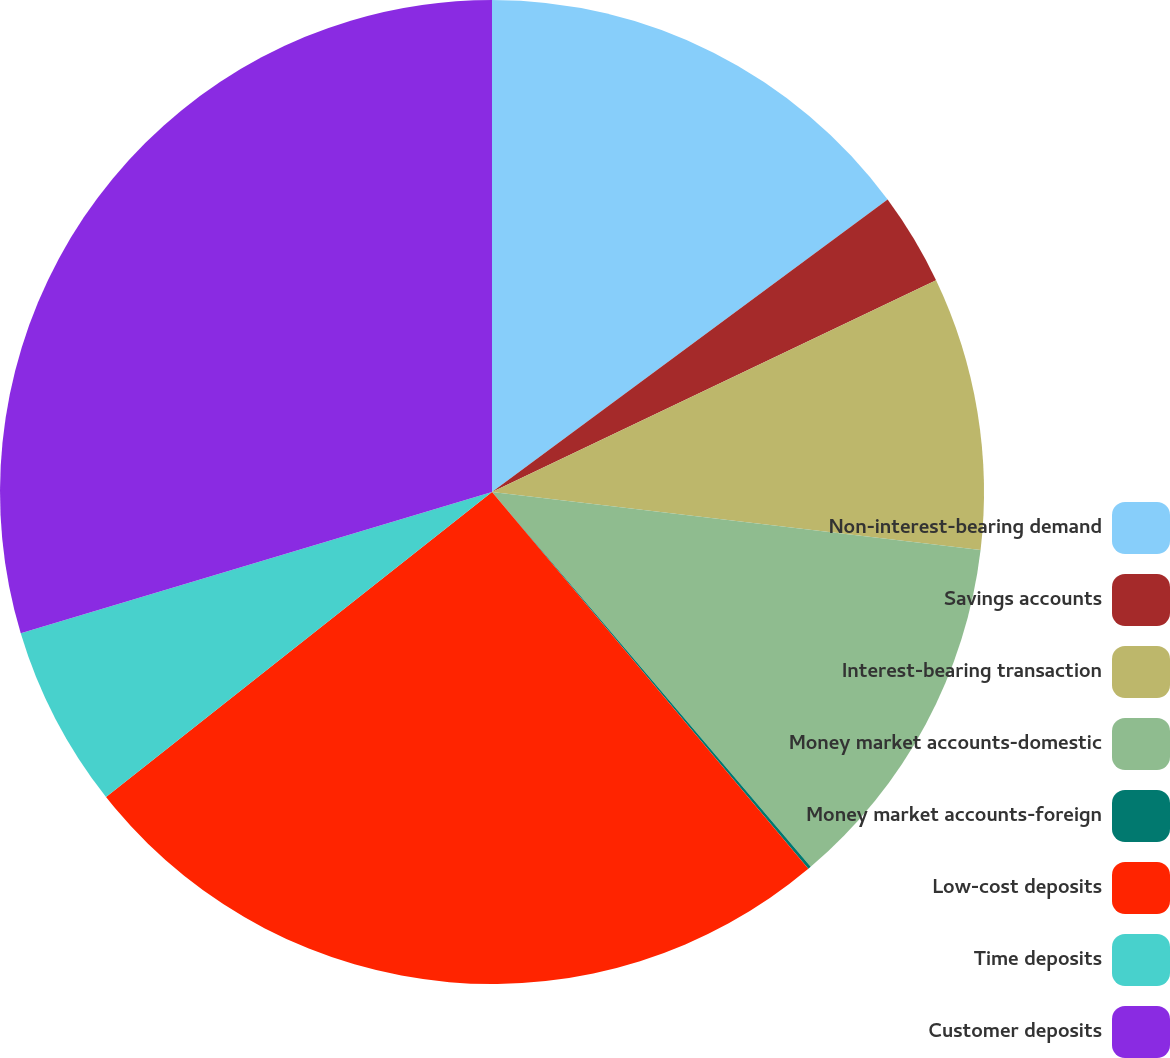Convert chart. <chart><loc_0><loc_0><loc_500><loc_500><pie_chart><fcel>Non-interest-bearing demand<fcel>Savings accounts<fcel>Interest-bearing transaction<fcel>Money market accounts-domestic<fcel>Money market accounts-foreign<fcel>Low-cost deposits<fcel>Time deposits<fcel>Customer deposits<nl><fcel>14.87%<fcel>3.05%<fcel>8.96%<fcel>11.91%<fcel>0.1%<fcel>25.47%<fcel>6.01%<fcel>29.64%<nl></chart> 